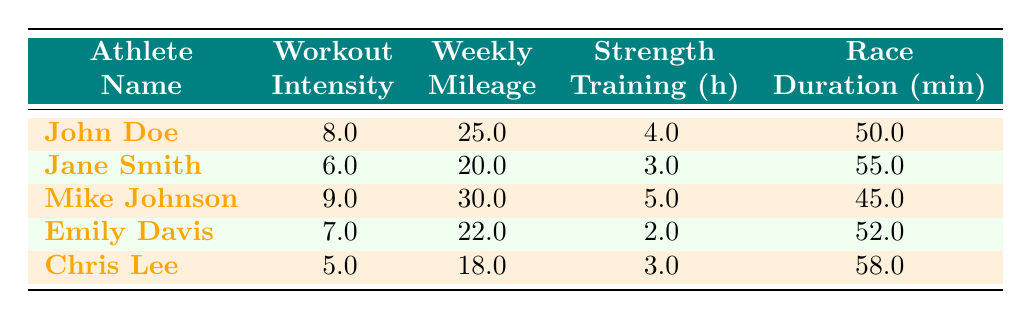What is the workout intensity of Mike Johnson? In the table, I find the row for Mike Johnson. Under the "Workout Intensity" column, it shows a value of 9.0.
Answer: 9.0 Which athlete has the shortest race duration? I need to look at the "Race Duration" column and find the smallest value. The durations listed are 50, 55, 45, 52, and 58. The smallest is 45, which corresponds to Mike Johnson.
Answer: Mike Johnson What is the average weekly mileage of all the athletes? To calculate the average, I first sum the weekly mileage: (25 + 20 + 30 + 22 + 18) = 115. Then I divide by the number of athletes, which is 5. So, 115 / 5 = 23.
Answer: 23 Is Jane Smith's workout intensity greater than Emily Davis's? I compare the "Workout Intensity" values for both athletes: Jane Smith has 6.0, and Emily Davis has 7.0. Since 6.0 is not greater than 7.0, the answer is no.
Answer: No What is the difference in race duration between John Doe and Chris Lee? First, I find their race durations: John Doe has 50 minutes and Chris Lee has 58 minutes. The difference is 58 - 50 = 8 minutes.
Answer: 8 minutes Do any athletes have the same workout intensity? I check the "Workout Intensity" values: 8, 6, 9, 7, and 5 are all unique. Therefore, no athletes share the same intensity value.
Answer: No What is the combined strength training hours of all athletes? I find the strength training hours: 4 + 3 + 5 + 2 + 3 = 17 hours total.
Answer: 17 hours Which athlete has the highest workout intensity, and what is their race duration? I scan the "Workout Intensity" values and find Mike Johnson has the highest at 9.0. Under his row, the "Race Duration" is 45 minutes.
Answer: Mike Johnson, 45 minutes What is the relationship between weekly mileage and race duration for athletes? I examine the data; generally, as weekly mileage increases, race duration decreases. For instance, higher weekly mileage aligns with lower race times, indicating a negative correlation.
Answer: Negative correlation 